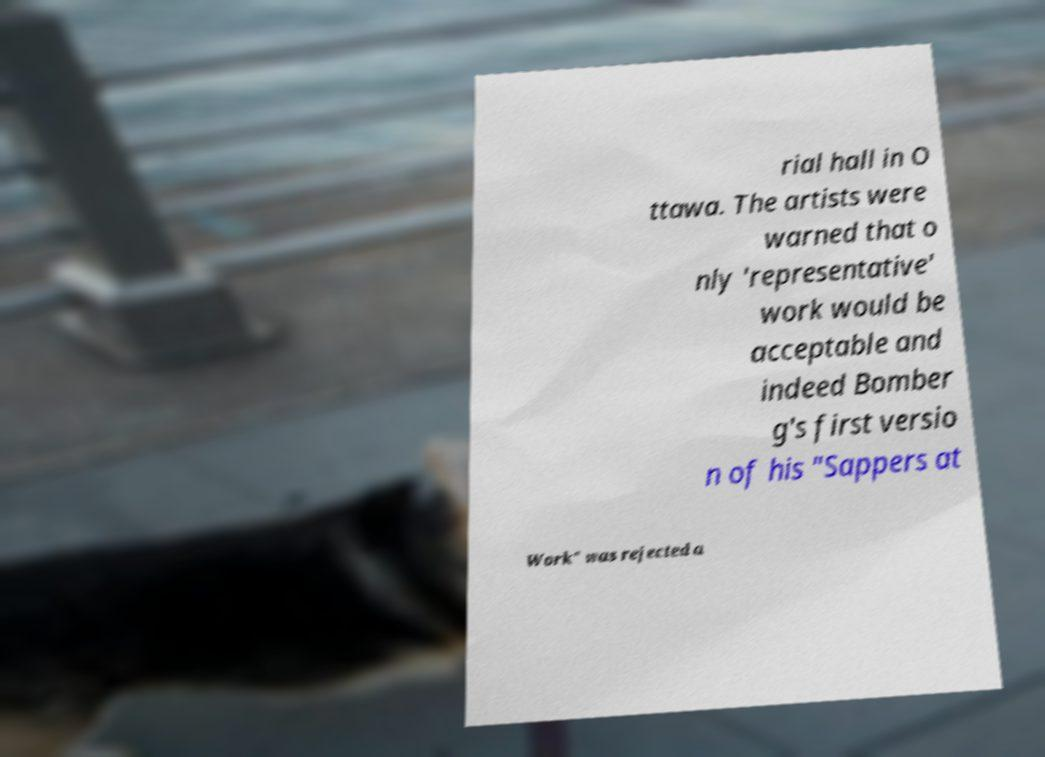Can you read and provide the text displayed in the image?This photo seems to have some interesting text. Can you extract and type it out for me? rial hall in O ttawa. The artists were warned that o nly 'representative' work would be acceptable and indeed Bomber g's first versio n of his "Sappers at Work" was rejected a 